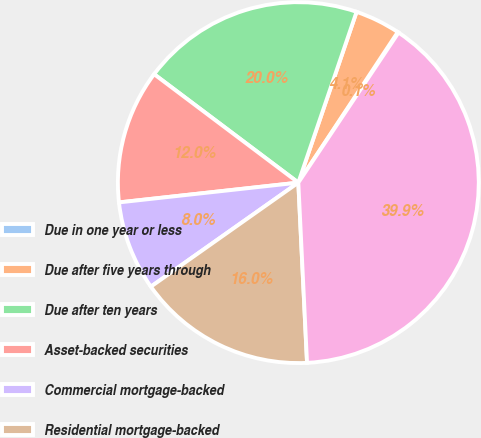<chart> <loc_0><loc_0><loc_500><loc_500><pie_chart><fcel>Due in one year or less<fcel>Due after five years through<fcel>Due after ten years<fcel>Asset-backed securities<fcel>Commercial mortgage-backed<fcel>Residential mortgage-backed<fcel>Total<nl><fcel>0.08%<fcel>4.06%<fcel>19.97%<fcel>12.01%<fcel>8.03%<fcel>15.99%<fcel>39.86%<nl></chart> 